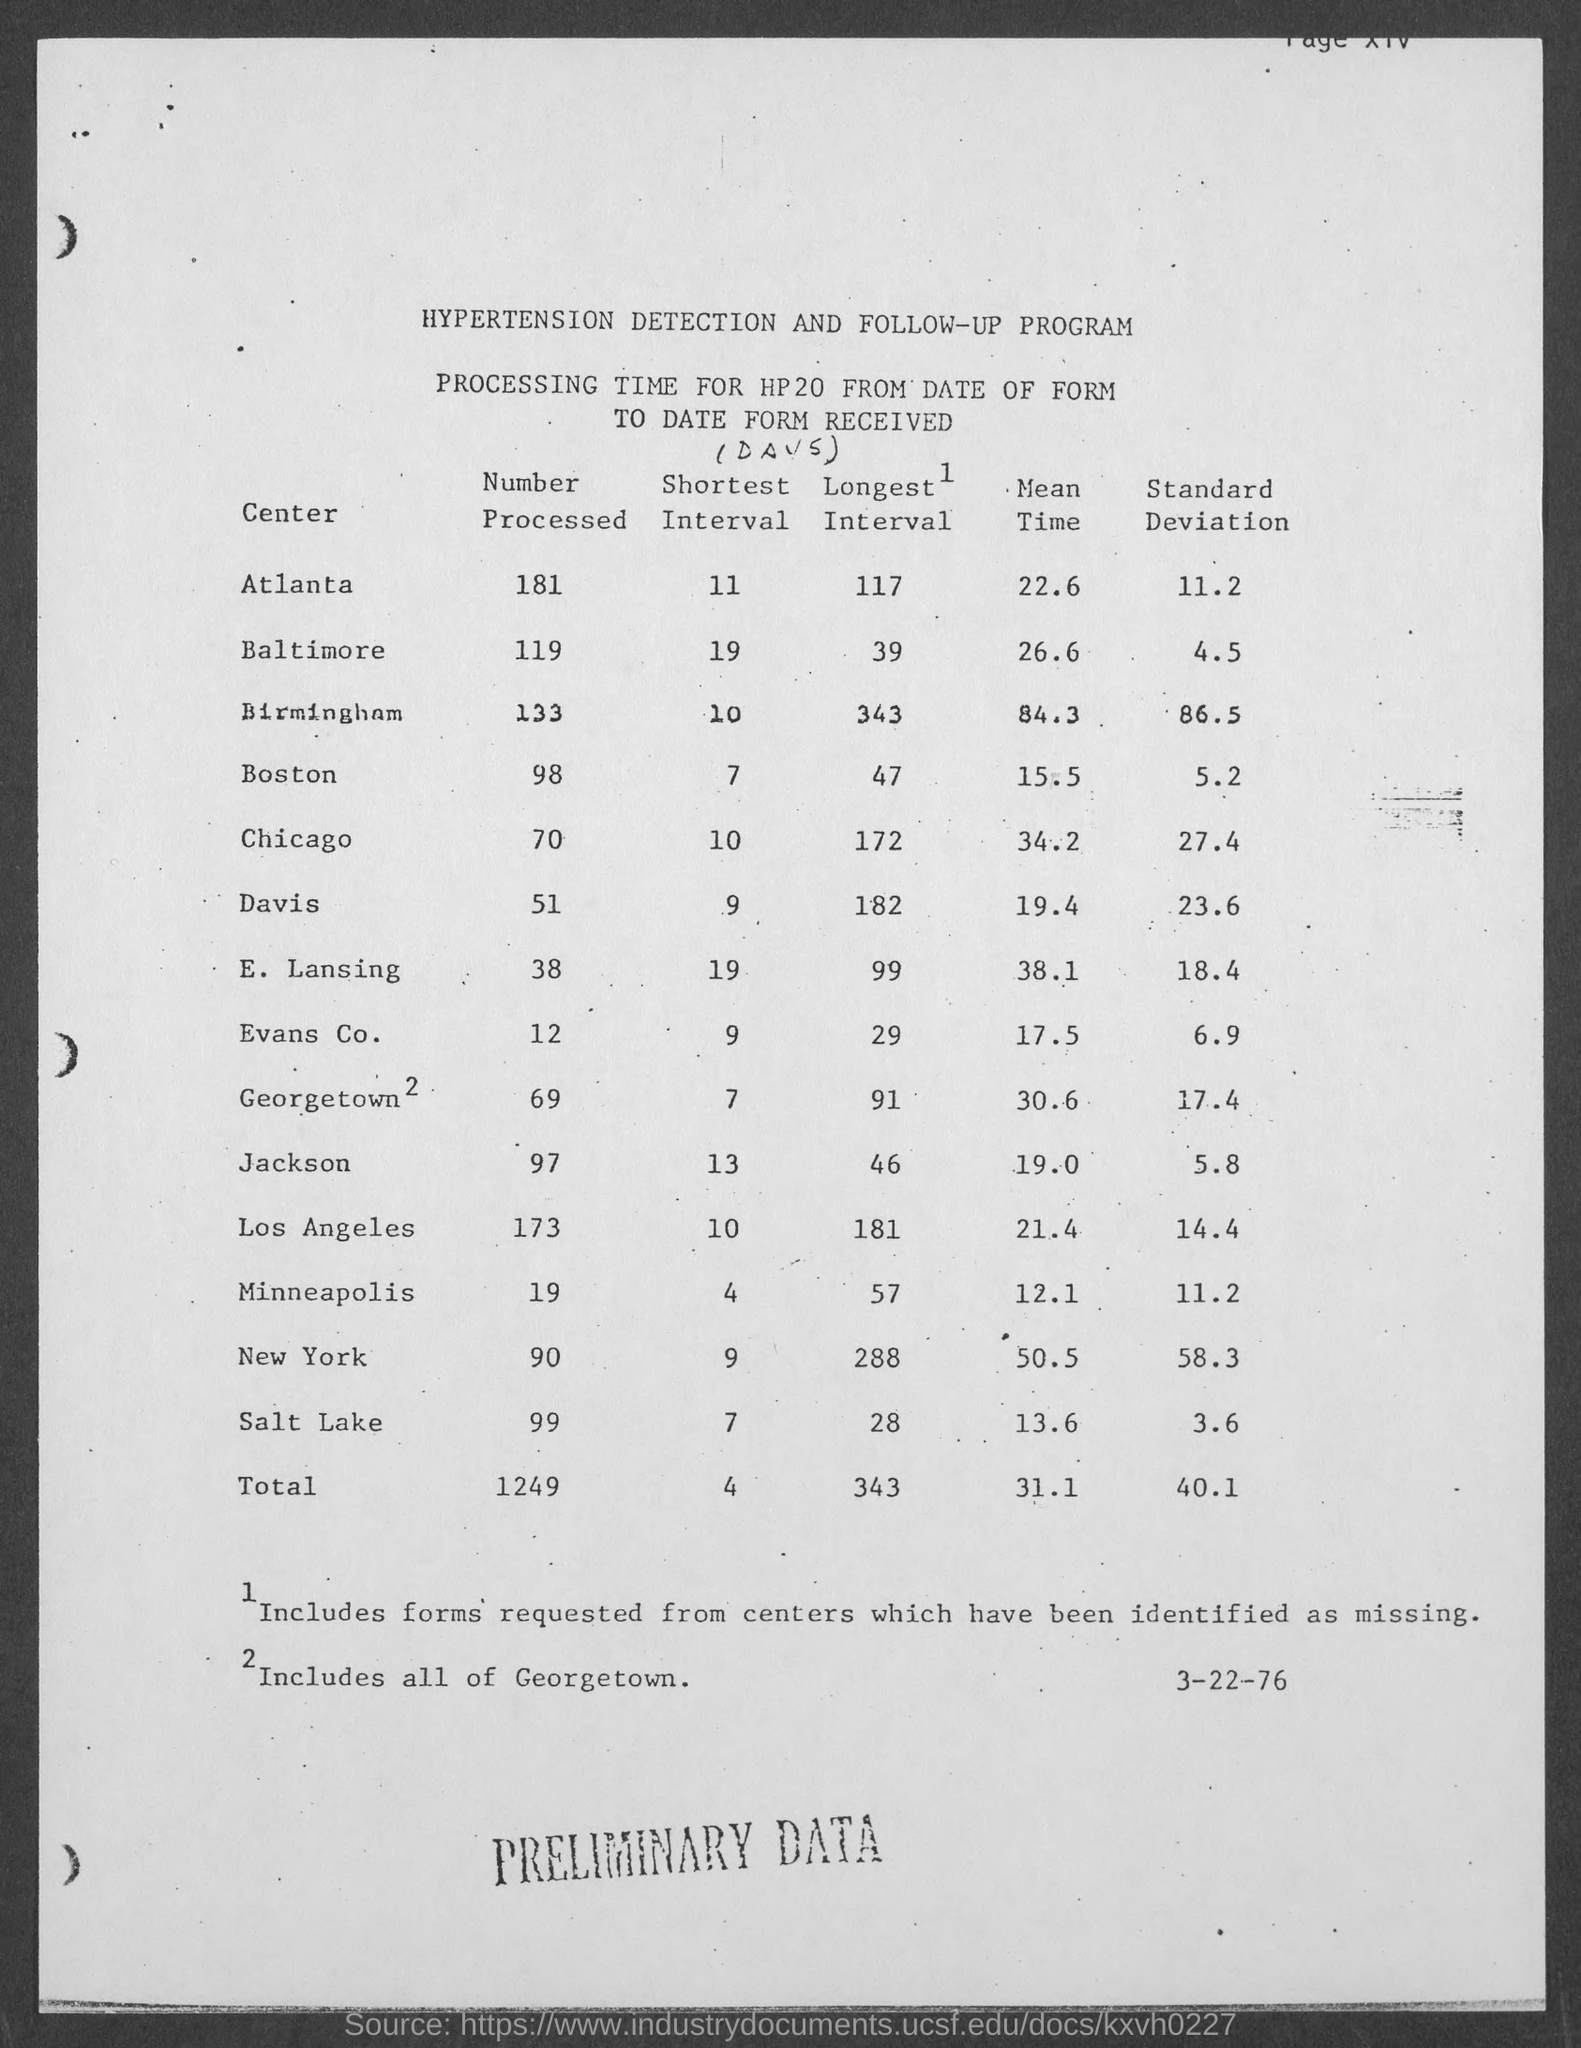Highlight a few significant elements in this photo. The standard deviation mentioned in the center of Baltimore is 4.5. The preliminary data was written in capital letters at the bottom of the page. The total number of processed forms received is 1249. The number of processed forms from Atlanta is 181. The number mentioned in the bottom right of the page is 3-22-76. 